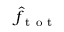Convert formula to latex. <formula><loc_0><loc_0><loc_500><loc_500>\hat { f } _ { t o t }</formula> 